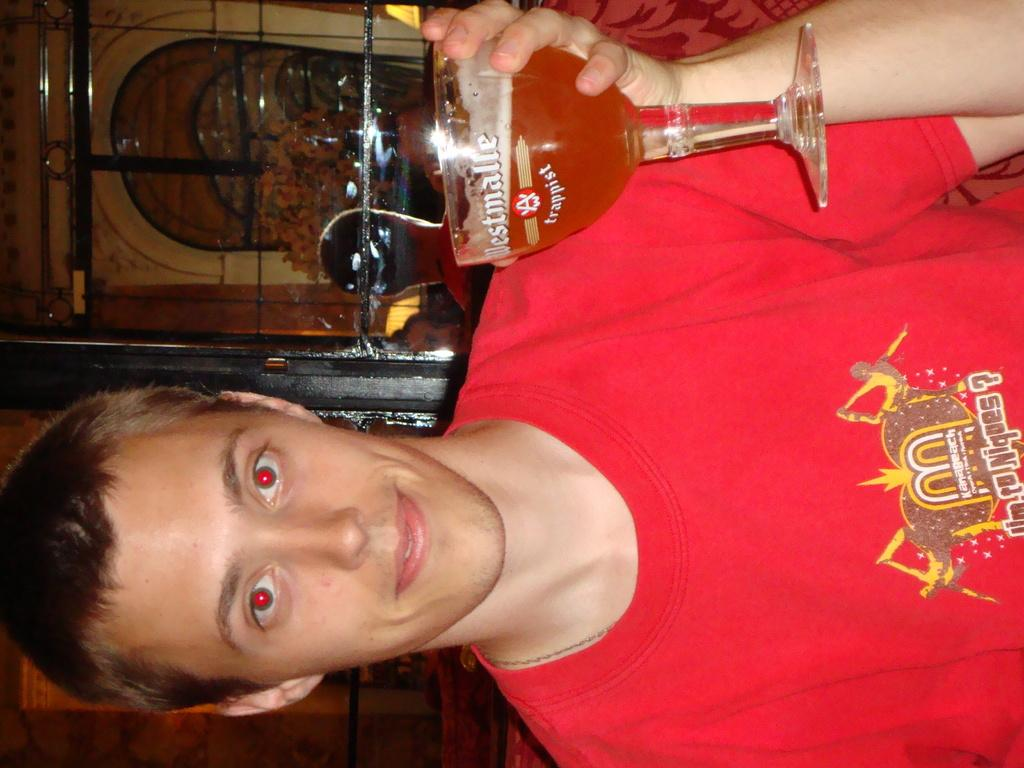What is the main subject of the picture? The main subject of the picture is a man. What is the man holding in his hand? The man is holding a glass in his hand. What is the man wearing? The man is wearing a red t-shirt. What type of grain is being used to make the payment in the image? There is no payment or grain present in the image; it features a man holding a glass. 